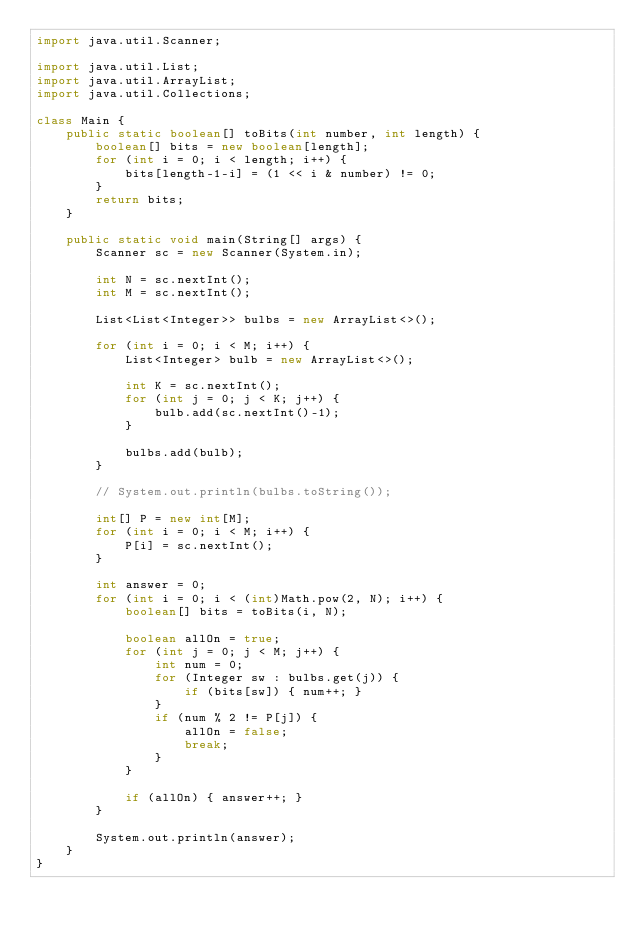Convert code to text. <code><loc_0><loc_0><loc_500><loc_500><_Java_>import java.util.Scanner;

import java.util.List;
import java.util.ArrayList;
import java.util.Collections;

class Main {
    public static boolean[] toBits(int number, int length) {
        boolean[] bits = new boolean[length];
        for (int i = 0; i < length; i++) {
            bits[length-1-i] = (1 << i & number) != 0;
        }
        return bits;
    }

    public static void main(String[] args) {
        Scanner sc = new Scanner(System.in);

        int N = sc.nextInt();
        int M = sc.nextInt();

        List<List<Integer>> bulbs = new ArrayList<>();

        for (int i = 0; i < M; i++) {
            List<Integer> bulb = new ArrayList<>();

            int K = sc.nextInt();
            for (int j = 0; j < K; j++) {
                bulb.add(sc.nextInt()-1);
            }

            bulbs.add(bulb);
        }

        // System.out.println(bulbs.toString());

        int[] P = new int[M];
        for (int i = 0; i < M; i++) {
            P[i] = sc.nextInt();
        }

        int answer = 0;
        for (int i = 0; i < (int)Math.pow(2, N); i++) {
            boolean[] bits = toBits(i, N);

            boolean allOn = true;
            for (int j = 0; j < M; j++) {
                int num = 0;
                for (Integer sw : bulbs.get(j)) {
                    if (bits[sw]) { num++; }
                }
                if (num % 2 != P[j]) {
                    allOn = false;
                    break;
                }
            }

            if (allOn) { answer++; }
        }

        System.out.println(answer);
    }
}
</code> 